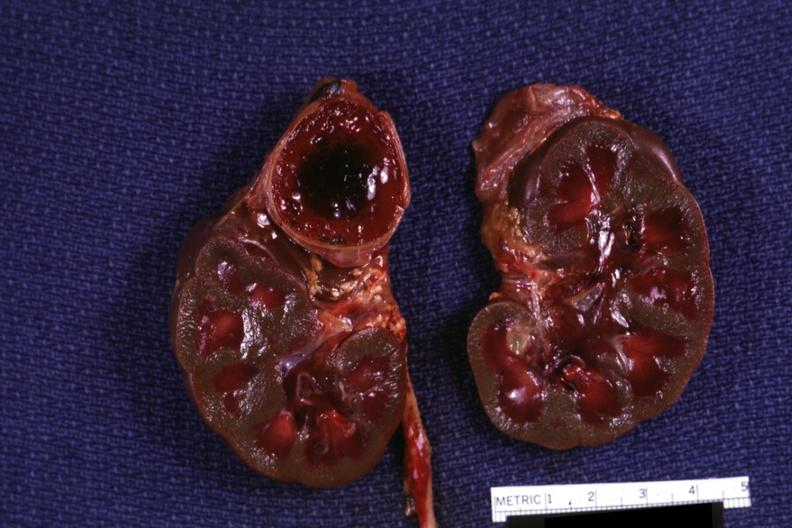what hemorrhage on one side kidneys are jaundiced?
Answer the question using a single word or phrase. Section of both and adrenals 